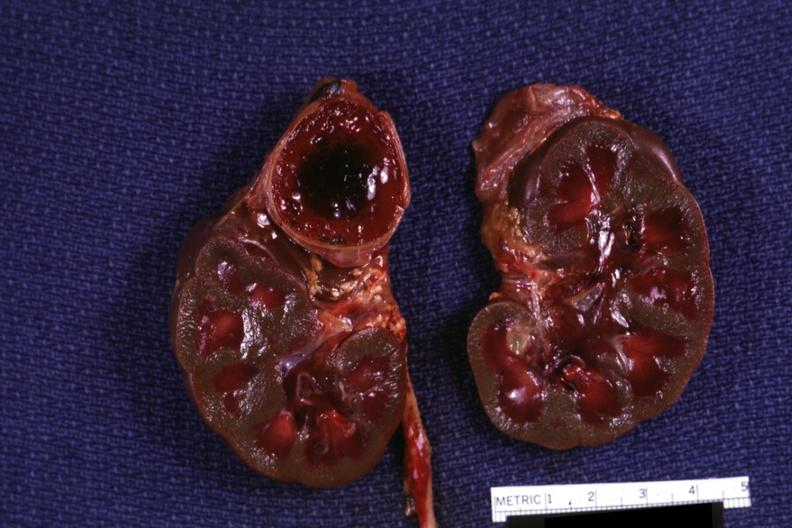what hemorrhage on one side kidneys are jaundiced?
Answer the question using a single word or phrase. Section of both and adrenals 